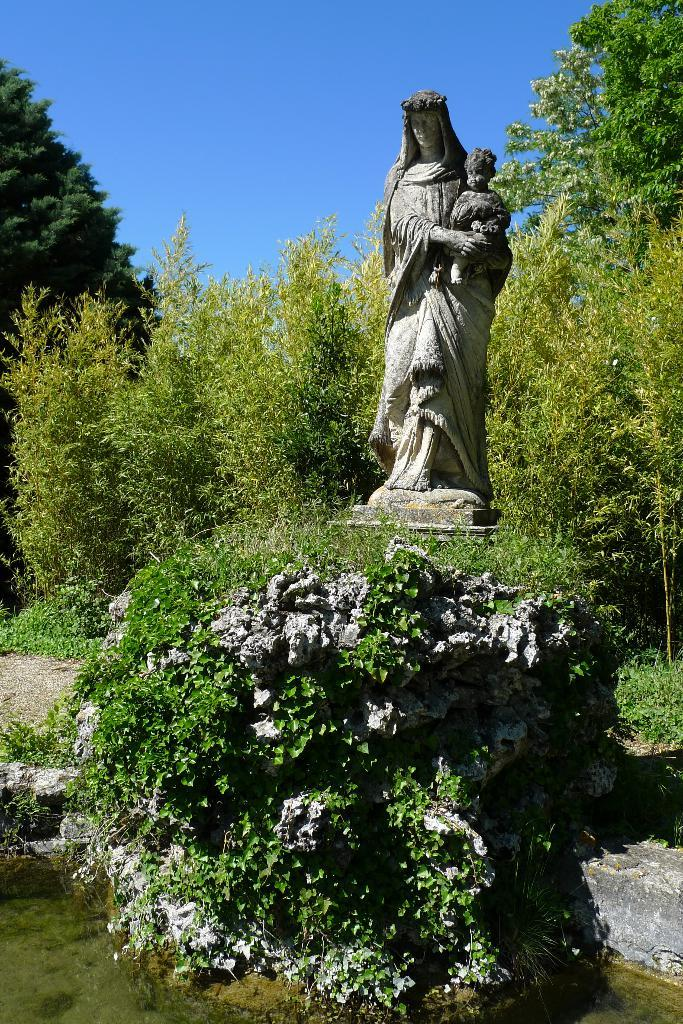What is the main subject of the image? There is a woman sculpture in the image. What is the woman sculpture holding? The woman sculpture is holding a baby. What can be seen in the background of the image? There are plants and trees in the background of the image. Where can the station be found in the image? There is no station present in the image. How many seats are visible in the image? There are no seats visible in the image. 